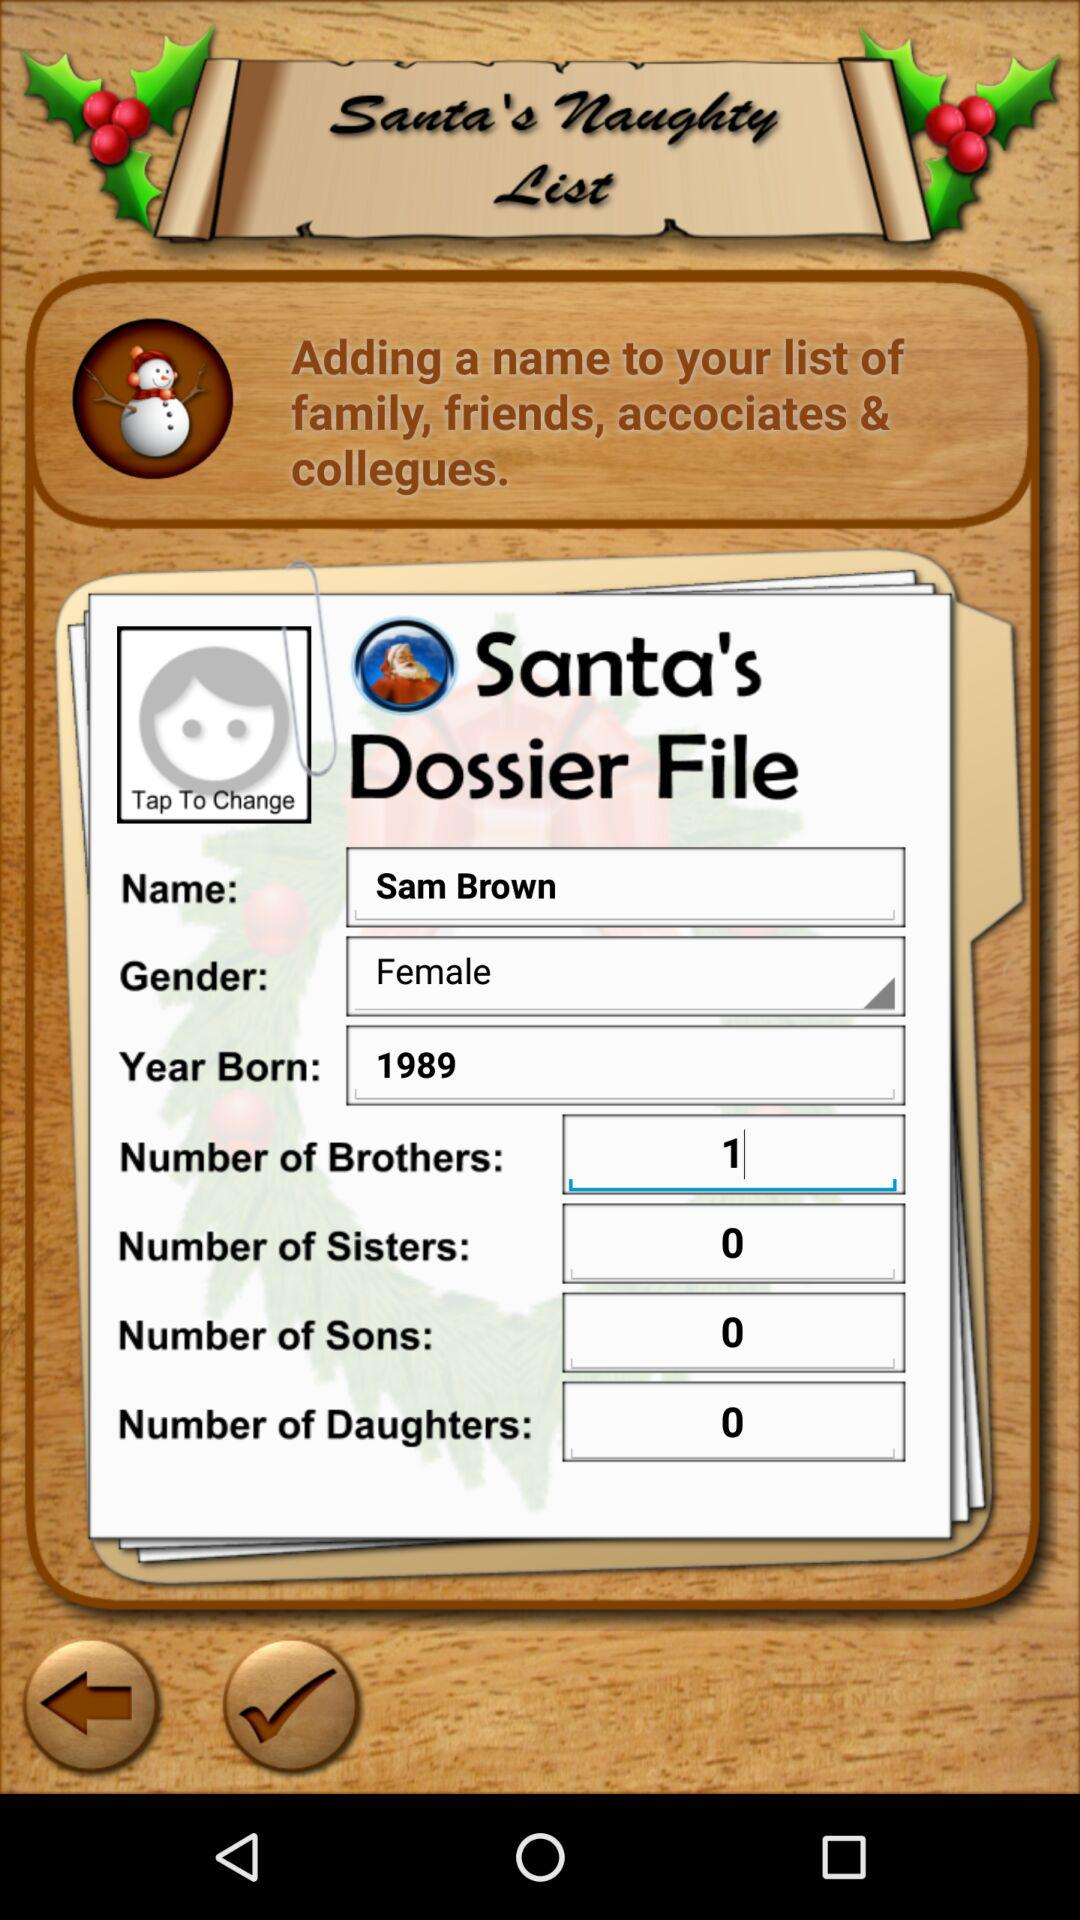What is the number of sons of the user? The number of sons is 0. 